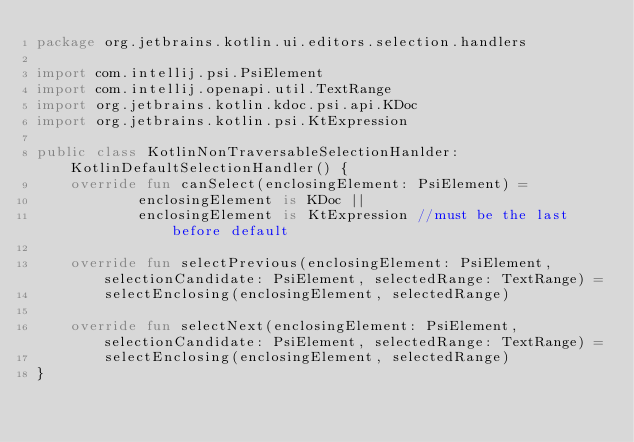<code> <loc_0><loc_0><loc_500><loc_500><_Kotlin_>package org.jetbrains.kotlin.ui.editors.selection.handlers

import com.intellij.psi.PsiElement
import com.intellij.openapi.util.TextRange
import org.jetbrains.kotlin.kdoc.psi.api.KDoc
import org.jetbrains.kotlin.psi.KtExpression

public class KotlinNonTraversableSelectionHanlder: KotlinDefaultSelectionHandler() {
	override fun canSelect(enclosingElement: PsiElement) = 
			enclosingElement is KDoc ||
			enclosingElement is KtExpression //must be the last before default 
	
	override fun selectPrevious(enclosingElement: PsiElement, selectionCandidate: PsiElement, selectedRange: TextRange) = 
		selectEnclosing(enclosingElement, selectedRange)
	
	override fun selectNext(enclosingElement: PsiElement, selectionCandidate: PsiElement, selectedRange: TextRange) = 
		selectEnclosing(enclosingElement, selectedRange)
}</code> 